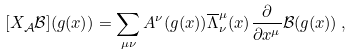<formula> <loc_0><loc_0><loc_500><loc_500>[ X _ { \mathcal { A } } \mathcal { B } ] ( g ( x ) ) = \sum _ { \mu \nu } A ^ { \nu } ( g ( x ) ) \overline { \Lambda } _ { \nu } ^ { \mu } ( x ) \frac { \partial } { \partial x ^ { \mu } } \mathcal { B } ( g ( x ) ) \, ,</formula> 